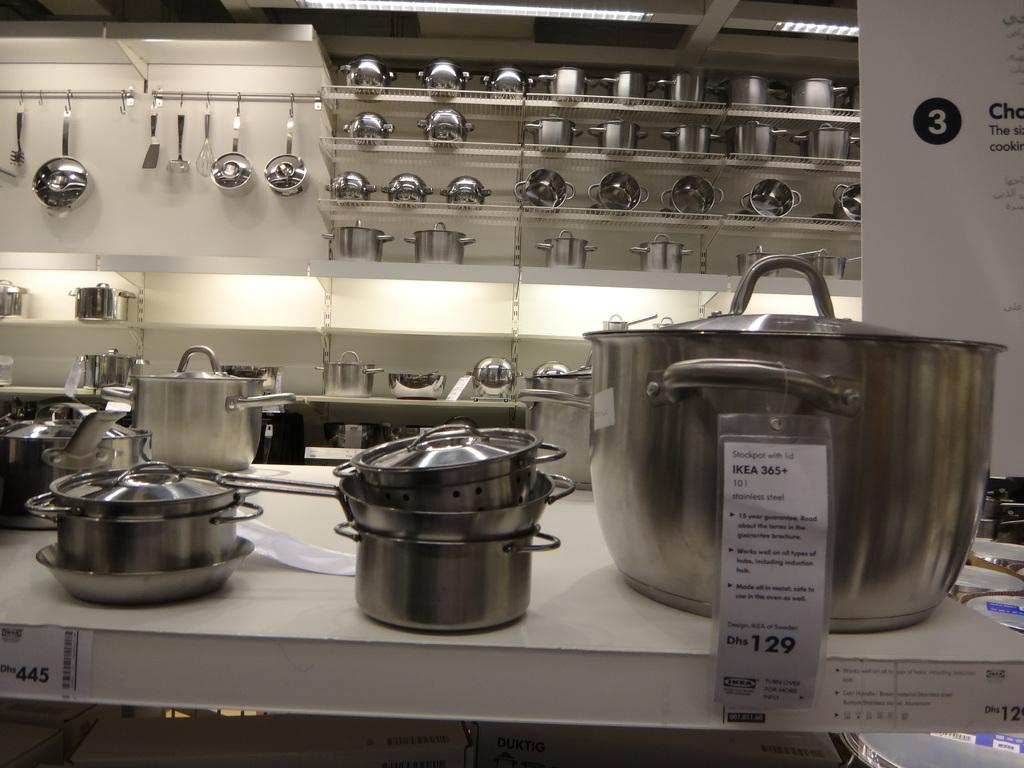<image>
Present a compact description of the photo's key features. Kitchen area at IKEA showing a stock pot for 129. 